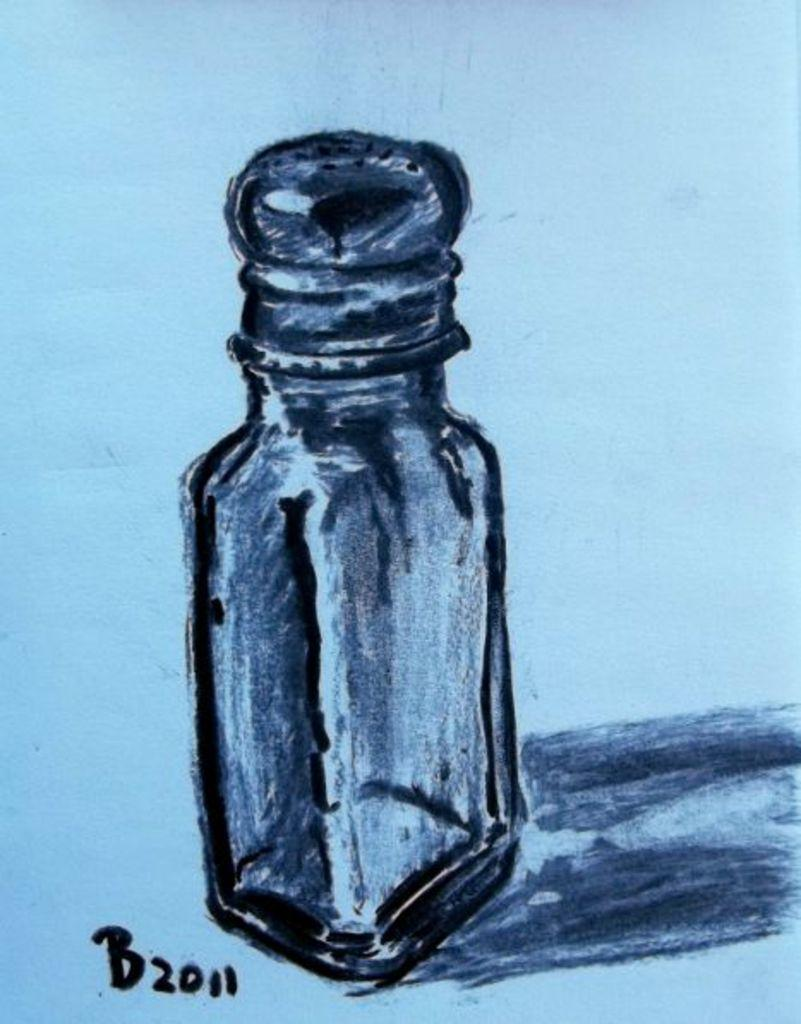<image>
Write a terse but informative summary of the picture. A drawing of a salt shaker is dated 2011. 